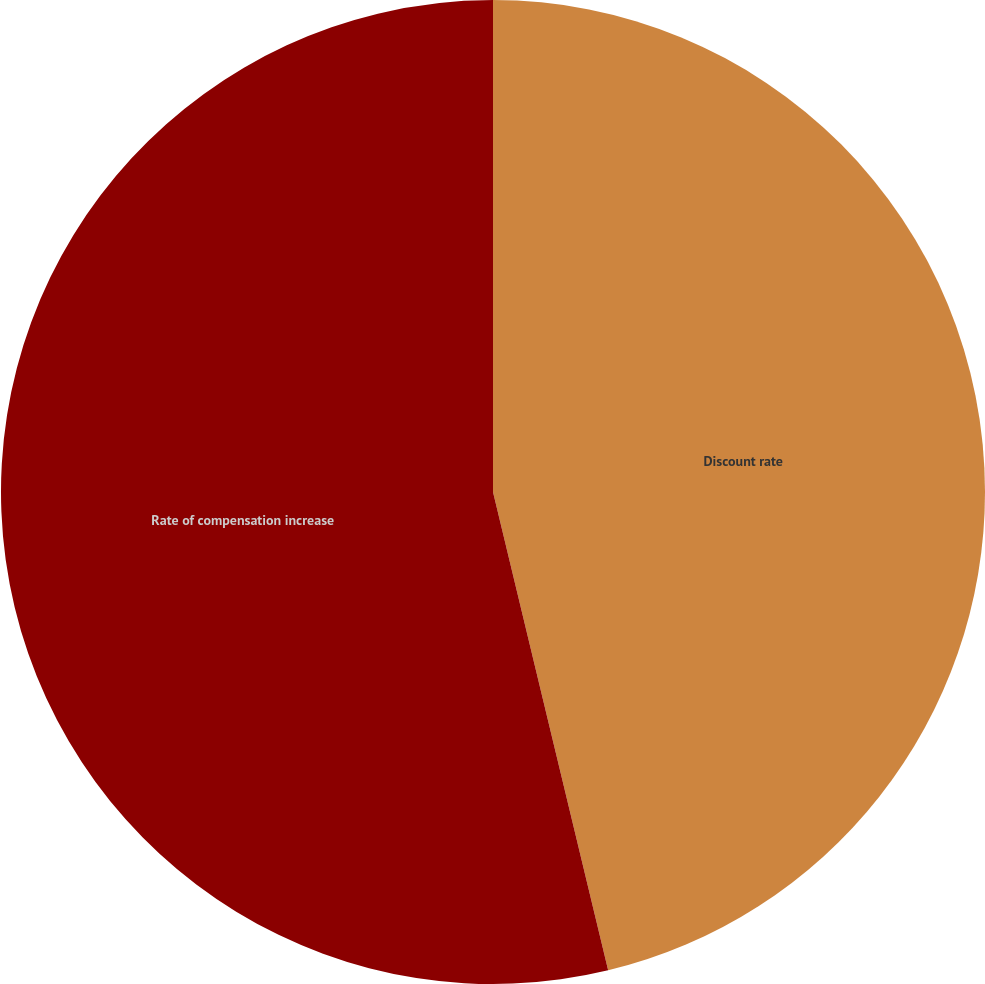Convert chart to OTSL. <chart><loc_0><loc_0><loc_500><loc_500><pie_chart><fcel>Discount rate<fcel>Rate of compensation increase<nl><fcel>46.24%<fcel>53.76%<nl></chart> 